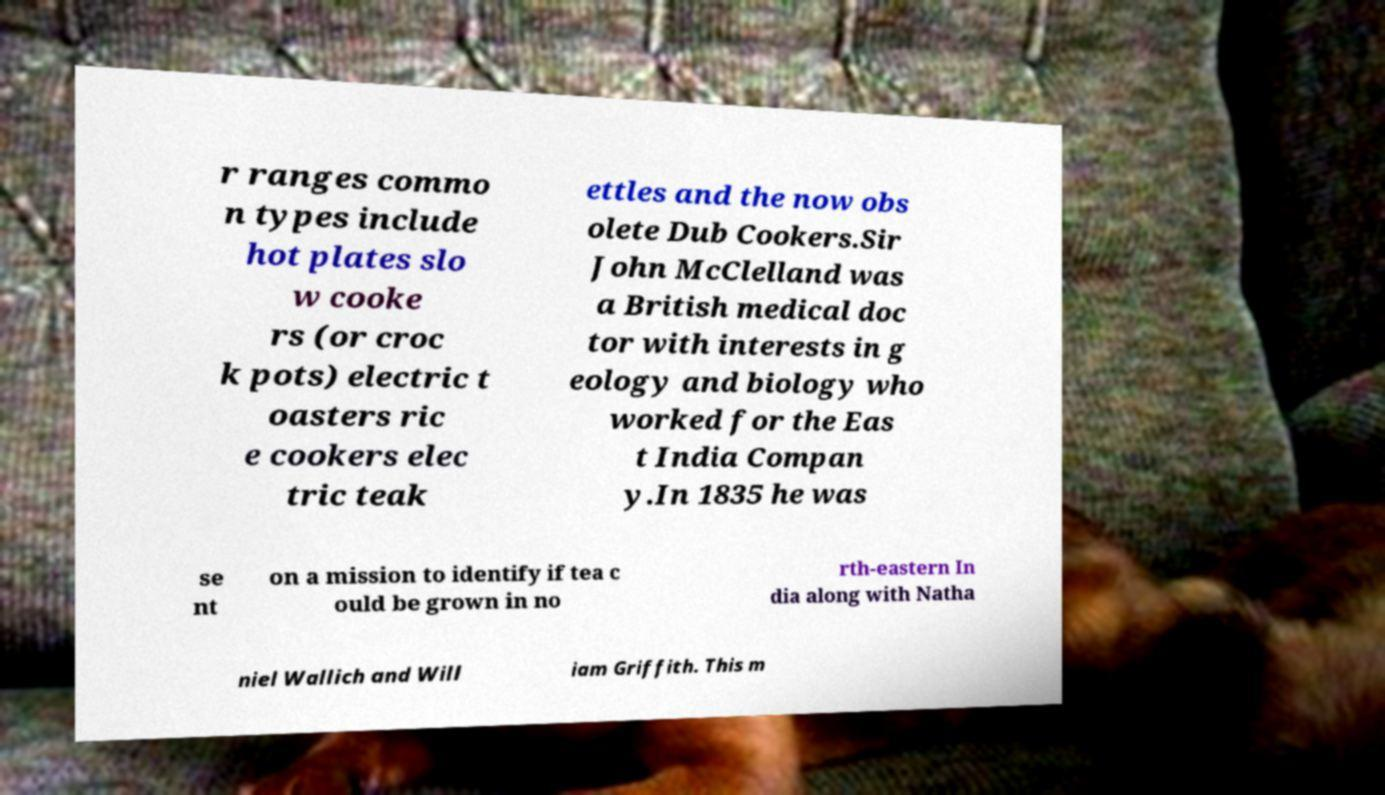Could you extract and type out the text from this image? r ranges commo n types include hot plates slo w cooke rs (or croc k pots) electric t oasters ric e cookers elec tric teak ettles and the now obs olete Dub Cookers.Sir John McClelland was a British medical doc tor with interests in g eology and biology who worked for the Eas t India Compan y.In 1835 he was se nt on a mission to identify if tea c ould be grown in no rth-eastern In dia along with Natha niel Wallich and Will iam Griffith. This m 